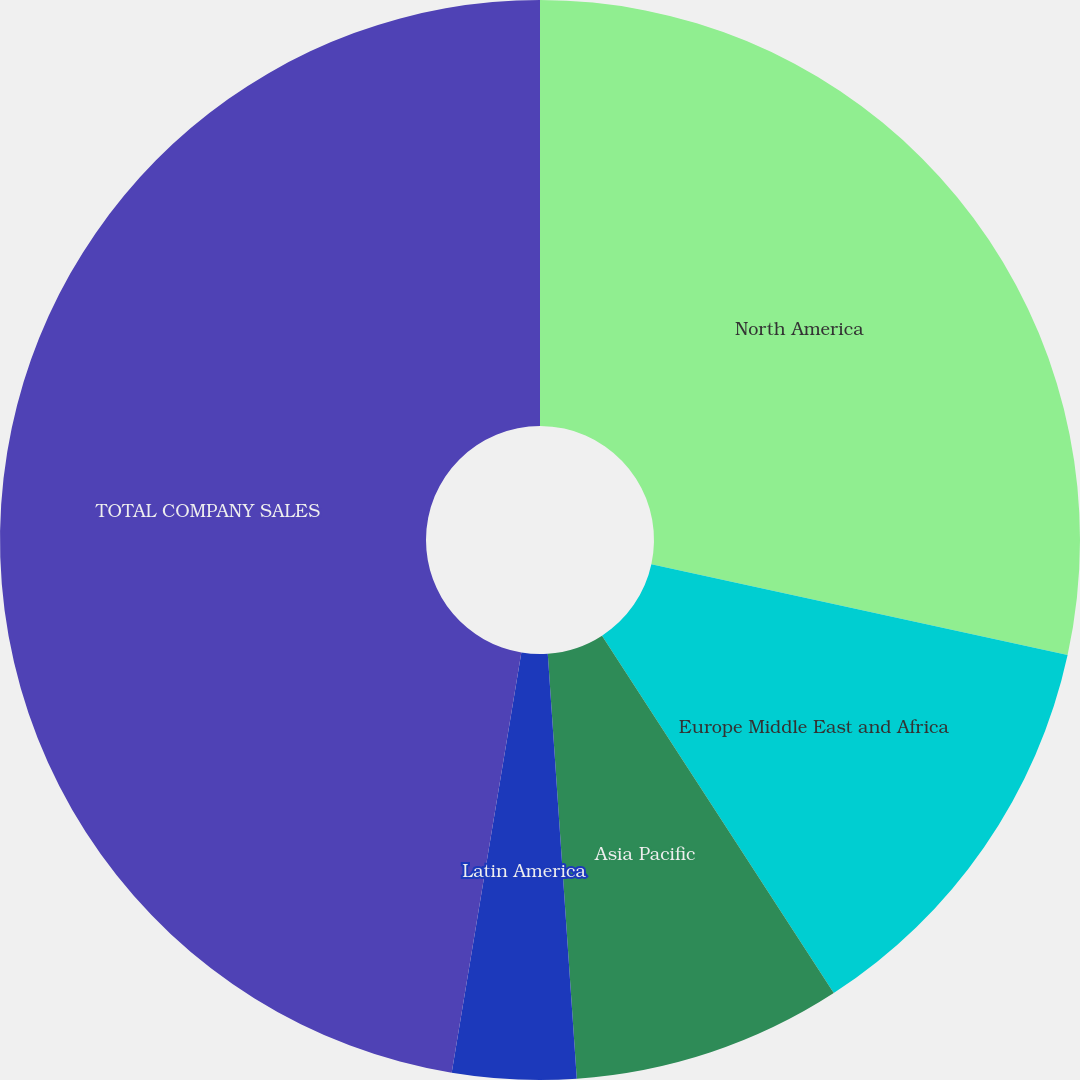Convert chart. <chart><loc_0><loc_0><loc_500><loc_500><pie_chart><fcel>North America<fcel>Europe Middle East and Africa<fcel>Asia Pacific<fcel>Latin America<fcel>TOTAL COMPANY SALES<nl><fcel>28.42%<fcel>12.43%<fcel>8.07%<fcel>3.7%<fcel>47.39%<nl></chart> 